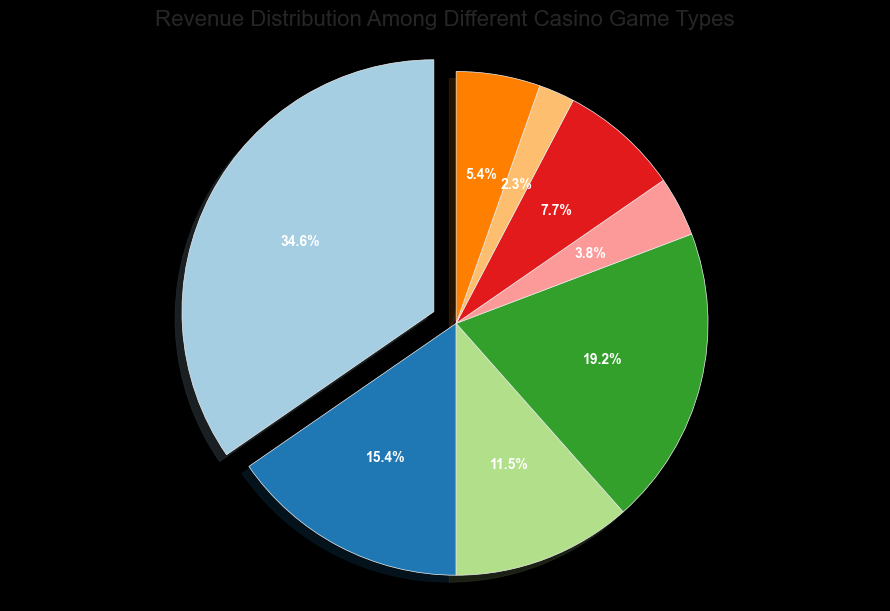Which game type generates the highest revenue? The plot highlights 'Slots' which is indicated by its larger slice and the percentage showing 45.2%.
Answer: Slots What is the total revenue from Blackjack and Poker combined? The revenue from Blackjack is 250 million and Poker is 200 million. Adding these gives 250 + 200 = 450 million.
Answer: 450 million Which game generates less revenue, Baccarat or Roulette? Both game types can be compared by their slices and percentages; Baccarat is 10.0% and Roulette is 15.1%. Thus, Baccarat generates less.
Answer: Baccarat How does the revenue from Keno compare to Craps? Keno generates 30 million while Craps generates 50 million. Comparing these values, Keno generates less.
Answer: Keno What's the combined revenue percentage of the four smallest game types? The smallest game types are Keno (3.0%), Craps (5.0%), Sports Betting (7.0%), and Baccarat (10.0%). Summing these: 3.0 + 5.0 + 7.0 + 10.0 = 25.0%.
Answer: 25.0% Which game type’s revenue is closest to one-third of the total revenue from Slots? One-third of Slot revenue is approximately 450/3 = 150 million. Roulette, with 150 million, matches this exactly.
Answer: Roulette How much more revenue do Slots generate compared to the sum of Roulette and Craps? Revenue from Roulette is 150 million and Craps is 50 million. Their sum is 150 + 50 = 200 million. Slots generate 450 million, so the difference is 450 - 200 = 250 million.
Answer: 250 million Arrange the game types from highest to lowest revenue. Slots (450 million), Blackjack (250 million), Poker (200 million), Roulette (150 million), Baccarat (100 million), Sports Betting (70 million), Craps (50 million), Keno (30 million).
Answer: Slots, Blackjack, Poker, Roulette, Baccarat, Sports Betting, Craps, Keno 